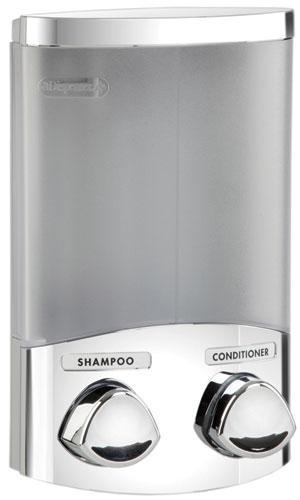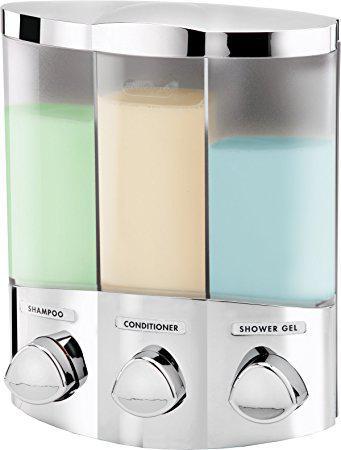The first image is the image on the left, the second image is the image on the right. Considering the images on both sides, is "The right image shows a soap dispenser that has both yellow and green liquid visible in separate compartments" valid? Answer yes or no. Yes. The first image is the image on the left, the second image is the image on the right. Considering the images on both sides, is "At least one dispenser is filled with a colored, non-white substance and dispenses more than one substance." valid? Answer yes or no. Yes. 